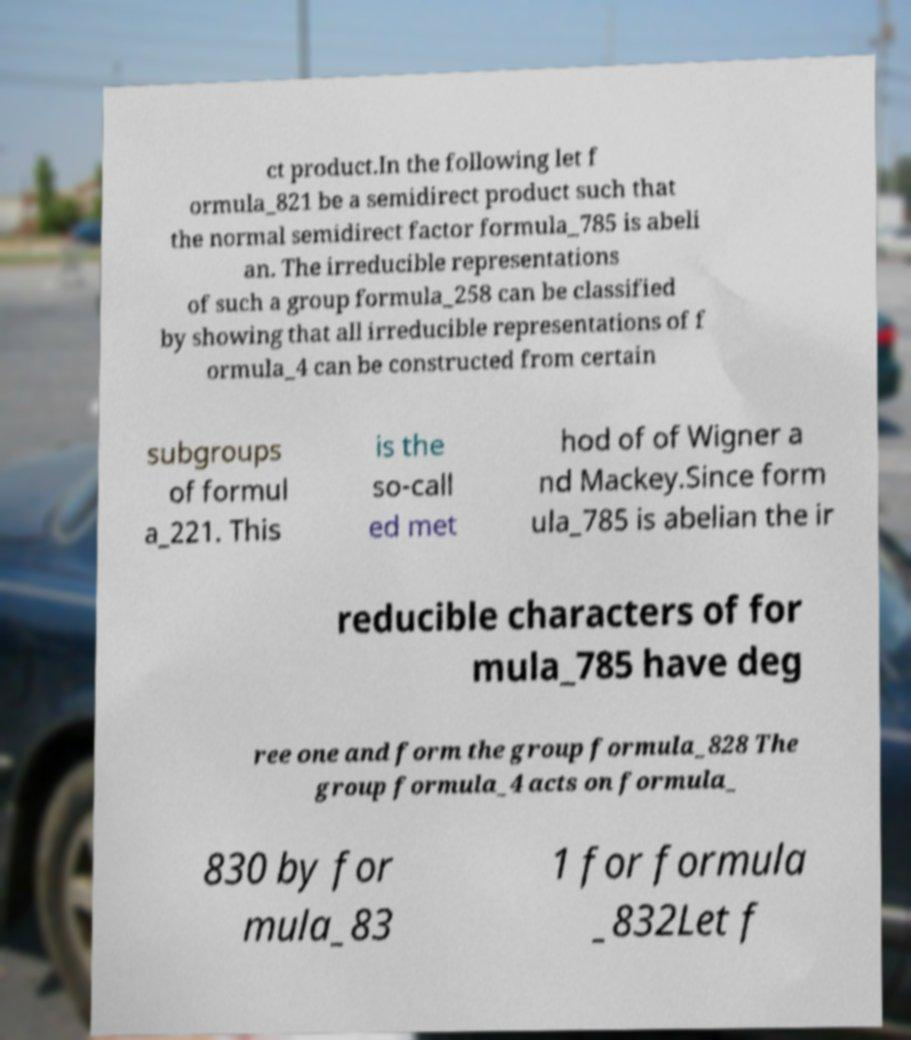Can you accurately transcribe the text from the provided image for me? ct product.In the following let f ormula_821 be a semidirect product such that the normal semidirect factor formula_785 is abeli an. The irreducible representations of such a group formula_258 can be classified by showing that all irreducible representations of f ormula_4 can be constructed from certain subgroups of formul a_221. This is the so-call ed met hod of of Wigner a nd Mackey.Since form ula_785 is abelian the ir reducible characters of for mula_785 have deg ree one and form the group formula_828 The group formula_4 acts on formula_ 830 by for mula_83 1 for formula _832Let f 